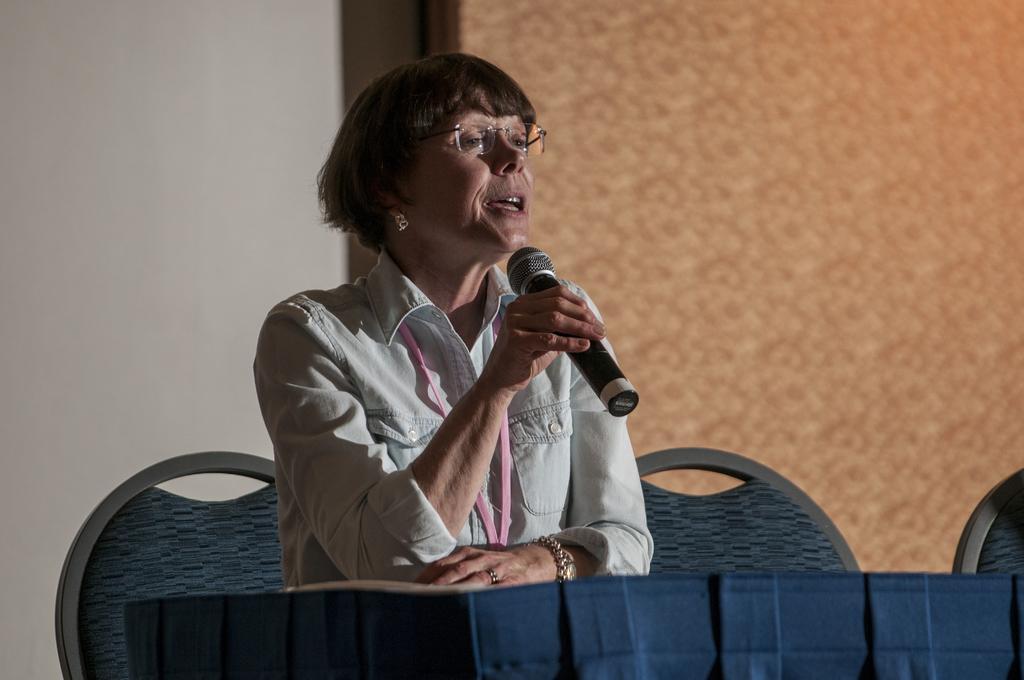In one or two sentences, can you explain what this image depicts? As we can see in the image there is a white color wall and a woman sitting on chair and talking on mic. In front of her there is a table. 